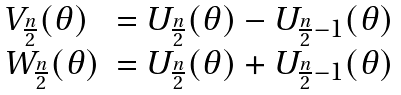<formula> <loc_0><loc_0><loc_500><loc_500>\begin{array} { l l } V _ { \frac { n } { 2 } } ( \theta ) & = U _ { \frac { n } { 2 } } ( \theta ) - U _ { \frac { n } { 2 } - 1 } ( \theta ) \\ W _ { \frac { n } { 2 } } ( \theta ) & = U _ { \frac { n } { 2 } } ( \theta ) + U _ { \frac { n } { 2 } - 1 } ( \theta ) \end{array}</formula> 